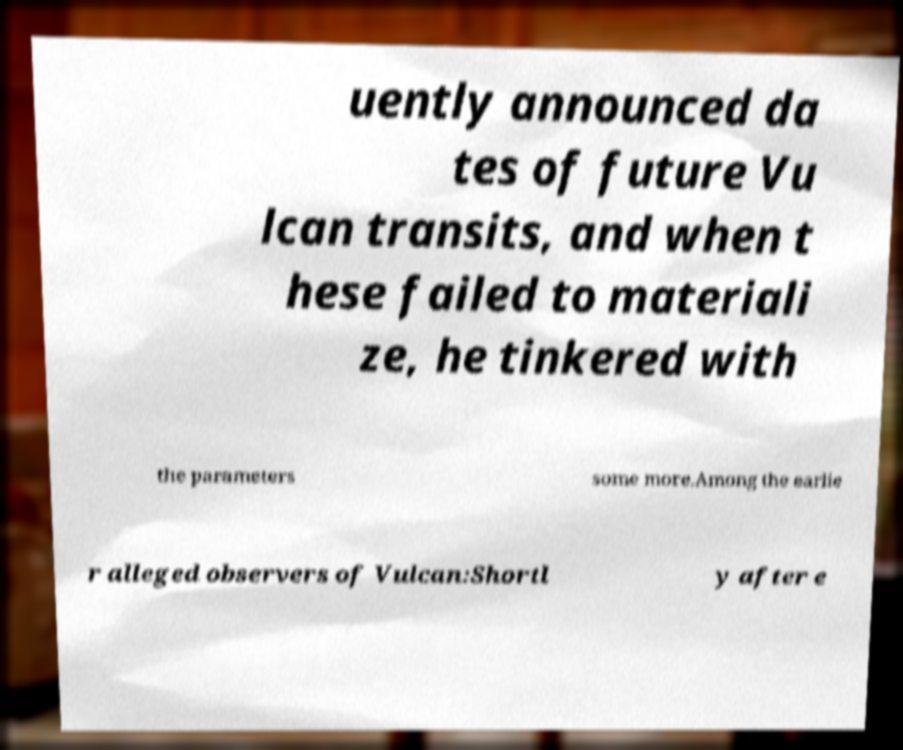Please identify and transcribe the text found in this image. uently announced da tes of future Vu lcan transits, and when t hese failed to materiali ze, he tinkered with the parameters some more.Among the earlie r alleged observers of Vulcan:Shortl y after e 